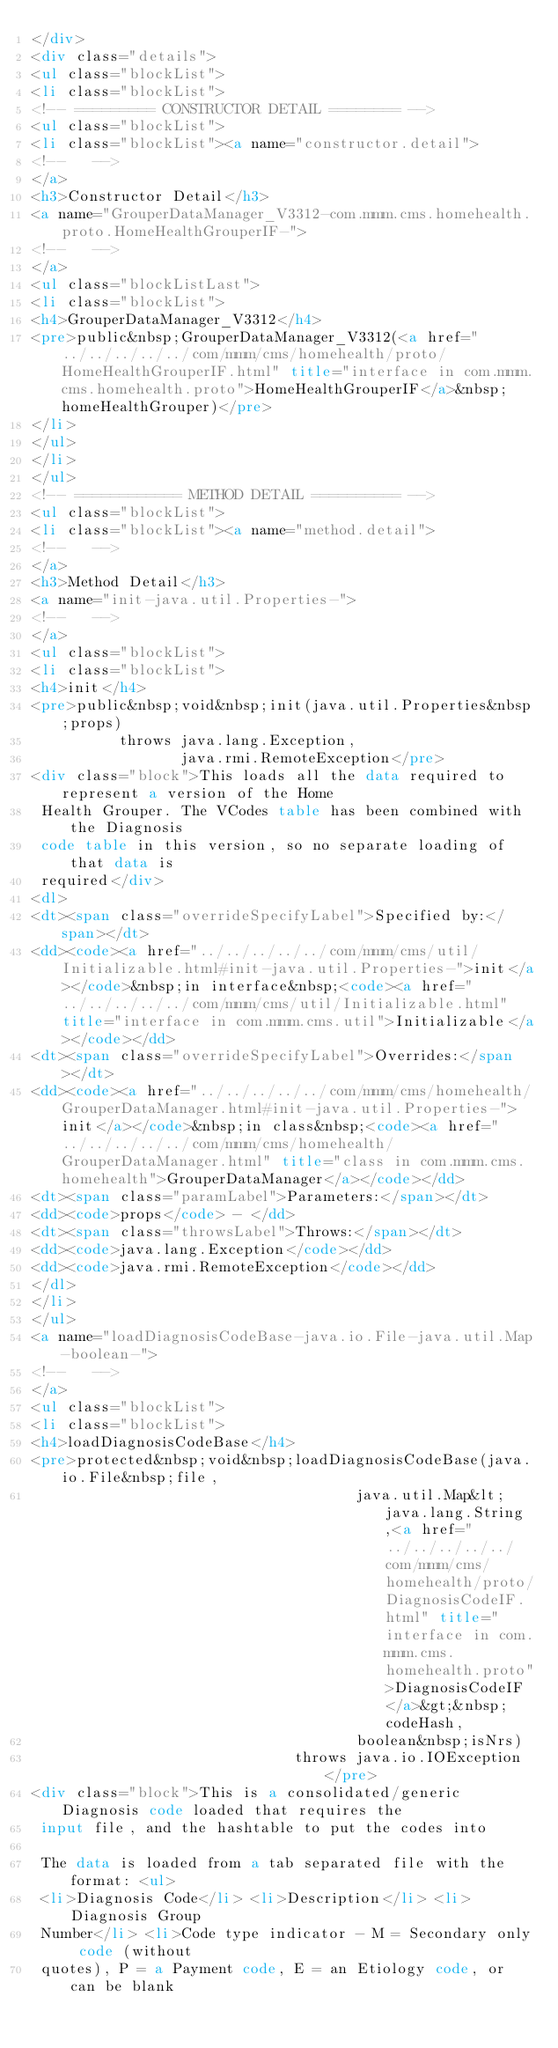Convert code to text. <code><loc_0><loc_0><loc_500><loc_500><_HTML_></div>
<div class="details">
<ul class="blockList">
<li class="blockList">
<!-- ========= CONSTRUCTOR DETAIL ======== -->
<ul class="blockList">
<li class="blockList"><a name="constructor.detail">
<!--   -->
</a>
<h3>Constructor Detail</h3>
<a name="GrouperDataManager_V3312-com.mmm.cms.homehealth.proto.HomeHealthGrouperIF-">
<!--   -->
</a>
<ul class="blockListLast">
<li class="blockList">
<h4>GrouperDataManager_V3312</h4>
<pre>public&nbsp;GrouperDataManager_V3312(<a href="../../../../../com/mmm/cms/homehealth/proto/HomeHealthGrouperIF.html" title="interface in com.mmm.cms.homehealth.proto">HomeHealthGrouperIF</a>&nbsp;homeHealthGrouper)</pre>
</li>
</ul>
</li>
</ul>
<!-- ============ METHOD DETAIL ========== -->
<ul class="blockList">
<li class="blockList"><a name="method.detail">
<!--   -->
</a>
<h3>Method Detail</h3>
<a name="init-java.util.Properties-">
<!--   -->
</a>
<ul class="blockList">
<li class="blockList">
<h4>init</h4>
<pre>public&nbsp;void&nbsp;init(java.util.Properties&nbsp;props)
          throws java.lang.Exception,
                 java.rmi.RemoteException</pre>
<div class="block">This loads all the data required to represent a version of the Home
 Health Grouper. The VCodes table has been combined with the Diagnosis
 code table in this version, so no separate loading of that data is
 required</div>
<dl>
<dt><span class="overrideSpecifyLabel">Specified by:</span></dt>
<dd><code><a href="../../../../../com/mmm/cms/util/Initializable.html#init-java.util.Properties-">init</a></code>&nbsp;in interface&nbsp;<code><a href="../../../../../com/mmm/cms/util/Initializable.html" title="interface in com.mmm.cms.util">Initializable</a></code></dd>
<dt><span class="overrideSpecifyLabel">Overrides:</span></dt>
<dd><code><a href="../../../../../com/mmm/cms/homehealth/GrouperDataManager.html#init-java.util.Properties-">init</a></code>&nbsp;in class&nbsp;<code><a href="../../../../../com/mmm/cms/homehealth/GrouperDataManager.html" title="class in com.mmm.cms.homehealth">GrouperDataManager</a></code></dd>
<dt><span class="paramLabel">Parameters:</span></dt>
<dd><code>props</code> - </dd>
<dt><span class="throwsLabel">Throws:</span></dt>
<dd><code>java.lang.Exception</code></dd>
<dd><code>java.rmi.RemoteException</code></dd>
</dl>
</li>
</ul>
<a name="loadDiagnosisCodeBase-java.io.File-java.util.Map-boolean-">
<!--   -->
</a>
<ul class="blockList">
<li class="blockList">
<h4>loadDiagnosisCodeBase</h4>
<pre>protected&nbsp;void&nbsp;loadDiagnosisCodeBase(java.io.File&nbsp;file,
                                     java.util.Map&lt;java.lang.String,<a href="../../../../../com/mmm/cms/homehealth/proto/DiagnosisCodeIF.html" title="interface in com.mmm.cms.homehealth.proto">DiagnosisCodeIF</a>&gt;&nbsp;codeHash,
                                     boolean&nbsp;isNrs)
                              throws java.io.IOException</pre>
<div class="block">This is a consolidated/generic Diagnosis code loaded that requires the
 input file, and the hashtable to put the codes into

 The data is loaded from a tab separated file with the format: <ul>
 <li>Diagnosis Code</li> <li>Description</li> <li>Diagnosis Group
 Number</li> <li>Code type indicator - M = Secondary only code (without
 quotes), P = a Payment code, E = an Etiology code, or can be blank</code> 